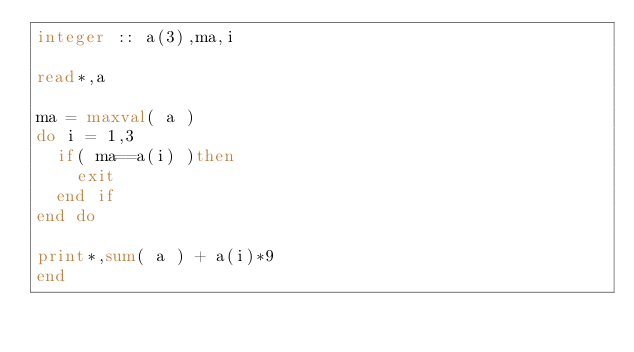Convert code to text. <code><loc_0><loc_0><loc_500><loc_500><_FORTRAN_>integer :: a(3),ma,i

read*,a

ma = maxval( a )
do i = 1,3
  if( ma==a(i) )then
    exit
  end if
end do

print*,sum( a ) + a(i)*9
end</code> 